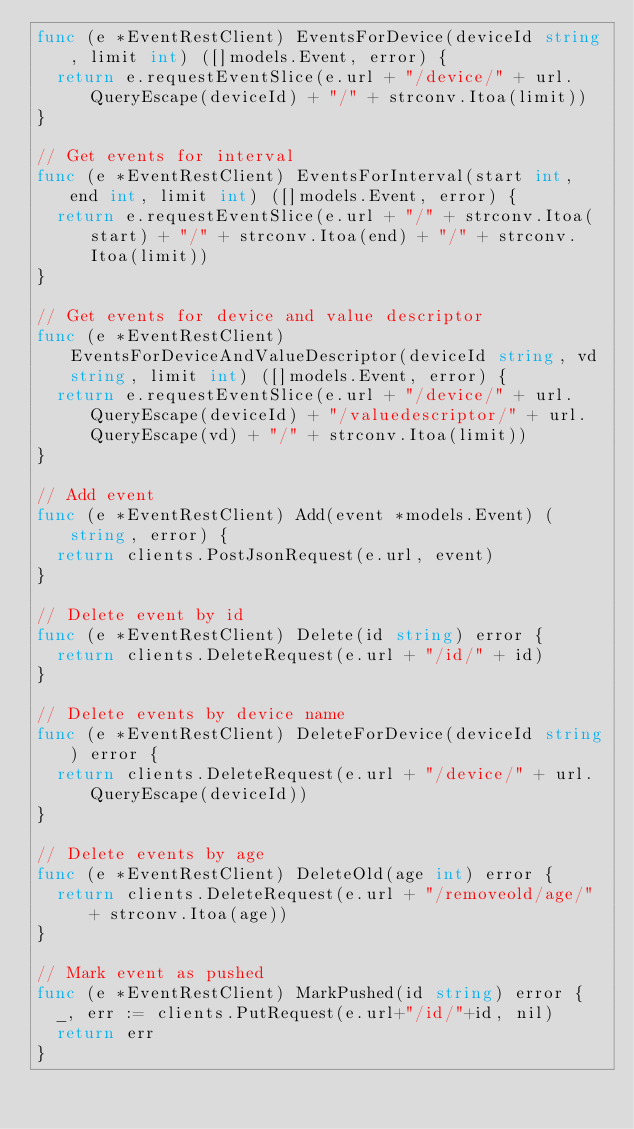<code> <loc_0><loc_0><loc_500><loc_500><_Go_>func (e *EventRestClient) EventsForDevice(deviceId string, limit int) ([]models.Event, error) {
	return e.requestEventSlice(e.url + "/device/" + url.QueryEscape(deviceId) + "/" + strconv.Itoa(limit))
}

// Get events for interval
func (e *EventRestClient) EventsForInterval(start int, end int, limit int) ([]models.Event, error) {
	return e.requestEventSlice(e.url + "/" + strconv.Itoa(start) + "/" + strconv.Itoa(end) + "/" + strconv.Itoa(limit))
}

// Get events for device and value descriptor
func (e *EventRestClient) EventsForDeviceAndValueDescriptor(deviceId string, vd string, limit int) ([]models.Event, error) {
	return e.requestEventSlice(e.url + "/device/" + url.QueryEscape(deviceId) + "/valuedescriptor/" + url.QueryEscape(vd) + "/" + strconv.Itoa(limit))
}

// Add event
func (e *EventRestClient) Add(event *models.Event) (string, error) {
	return clients.PostJsonRequest(e.url, event)
}

// Delete event by id
func (e *EventRestClient) Delete(id string) error {
	return clients.DeleteRequest(e.url + "/id/" + id)
}

// Delete events by device name
func (e *EventRestClient) DeleteForDevice(deviceId string) error {
	return clients.DeleteRequest(e.url + "/device/" + url.QueryEscape(deviceId))
}

// Delete events by age
func (e *EventRestClient) DeleteOld(age int) error {
	return clients.DeleteRequest(e.url + "/removeold/age/" + strconv.Itoa(age))
}

// Mark event as pushed
func (e *EventRestClient) MarkPushed(id string) error {
	_, err := clients.PutRequest(e.url+"/id/"+id, nil)
	return err
}
</code> 